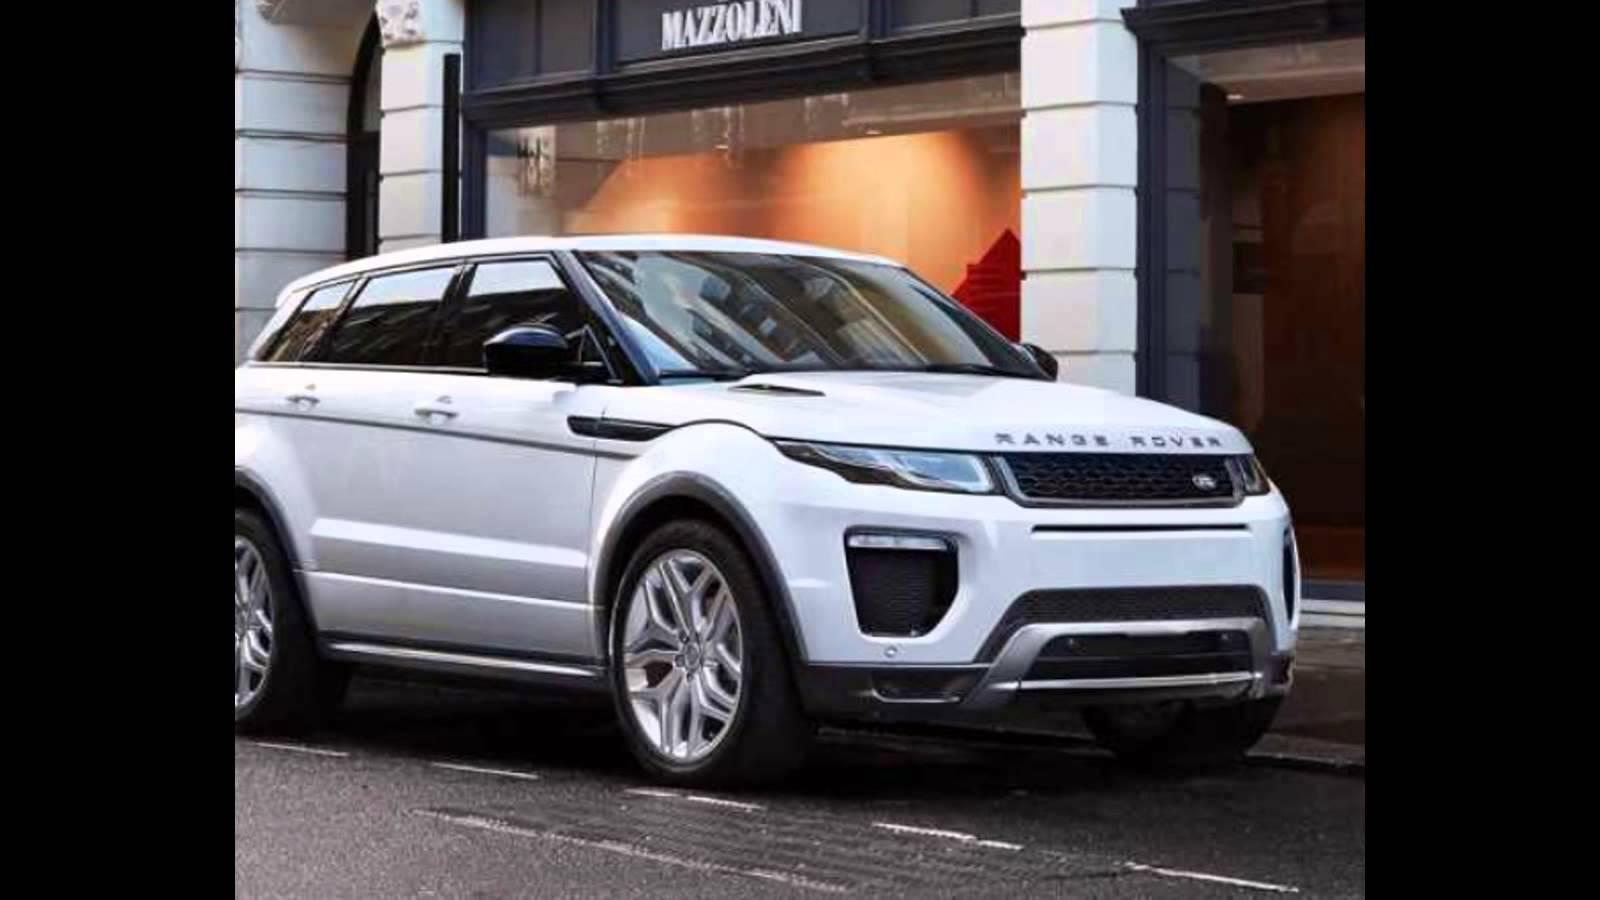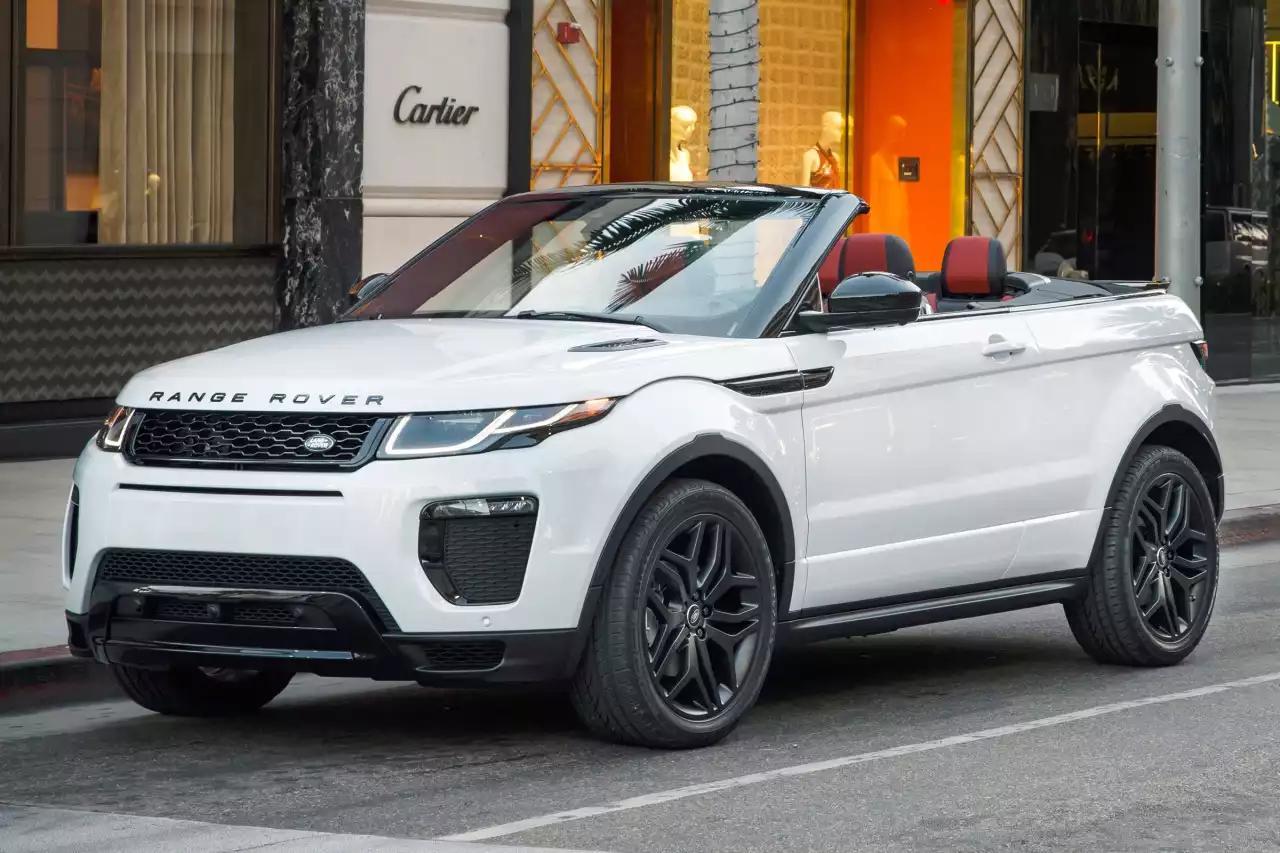The first image is the image on the left, the second image is the image on the right. For the images displayed, is the sentence "The right image contains a white vehicle that is facing towards the right." factually correct? Answer yes or no. No. 